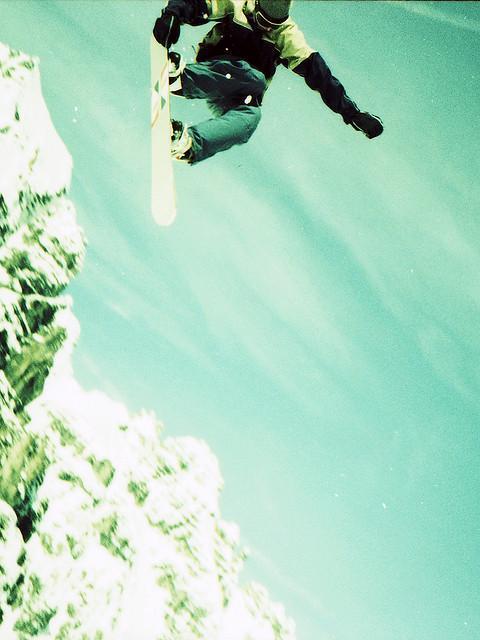How many chocolate donuts are there?
Give a very brief answer. 0. 